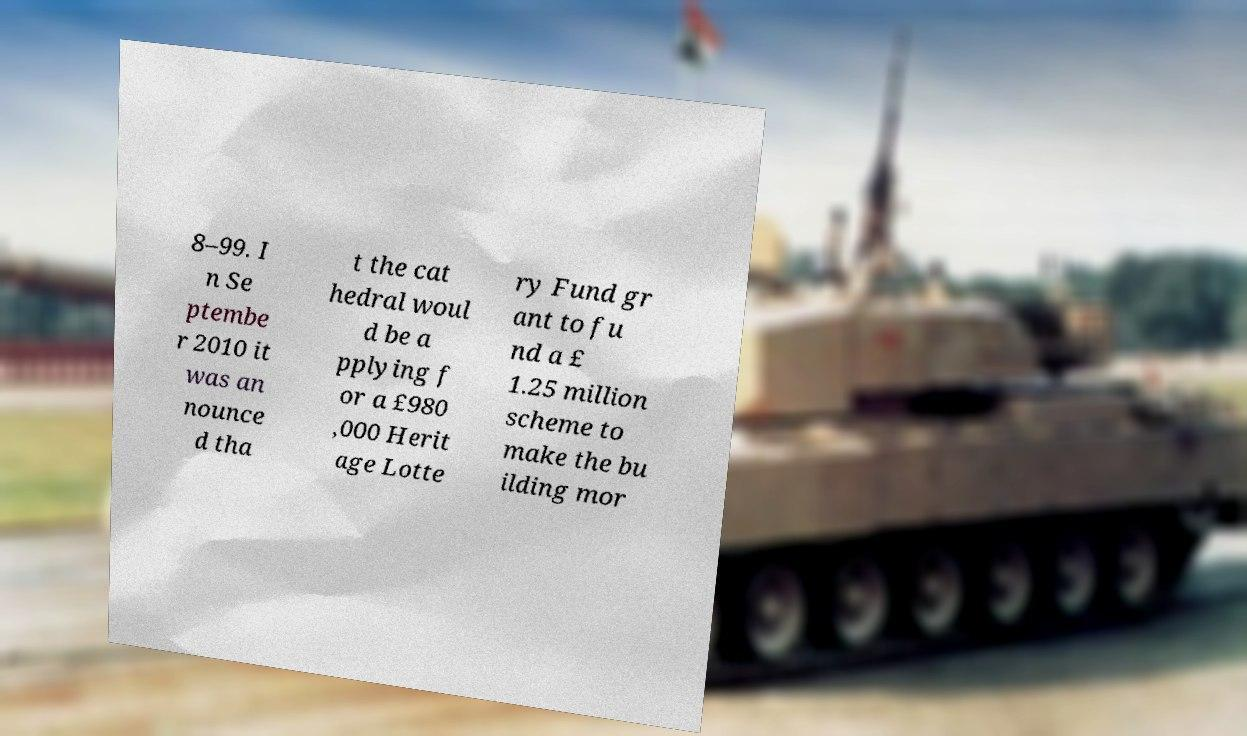For documentation purposes, I need the text within this image transcribed. Could you provide that? 8–99. I n Se ptembe r 2010 it was an nounce d tha t the cat hedral woul d be a pplying f or a £980 ,000 Herit age Lotte ry Fund gr ant to fu nd a £ 1.25 million scheme to make the bu ilding mor 